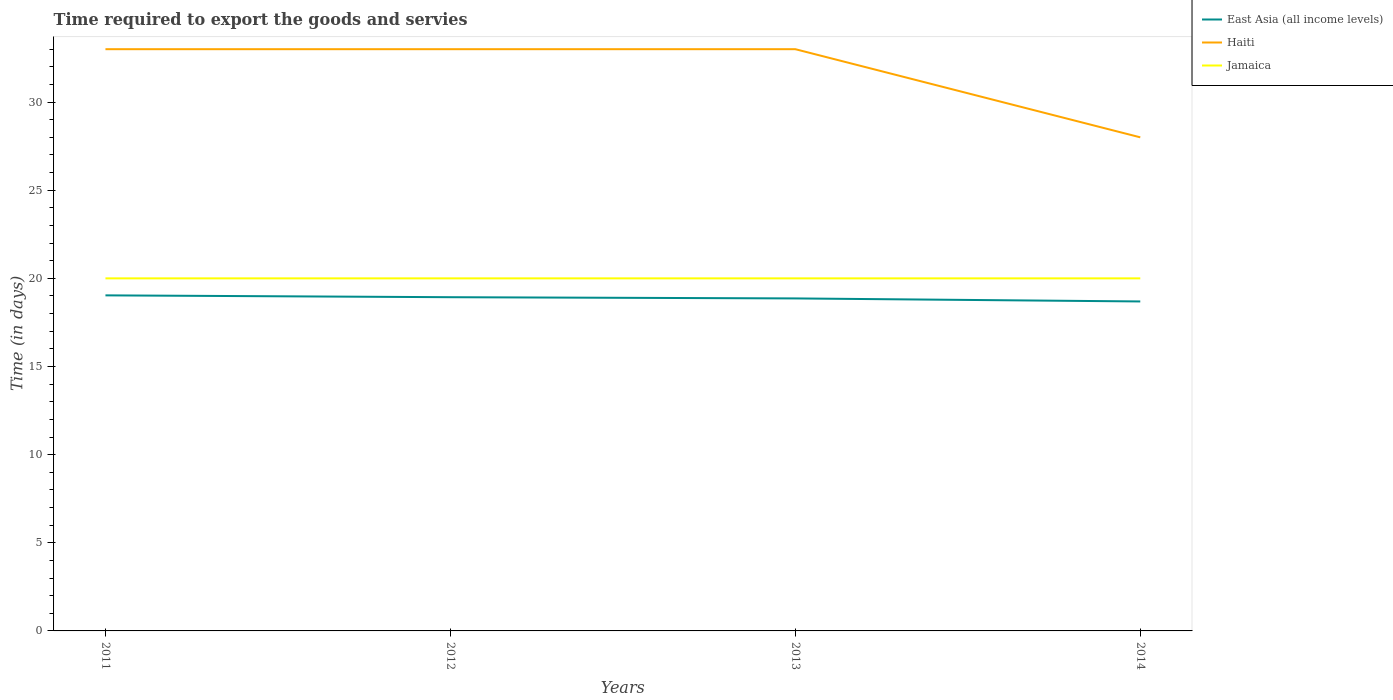Is the number of lines equal to the number of legend labels?
Offer a very short reply. Yes. Across all years, what is the maximum number of days required to export the goods and services in East Asia (all income levels)?
Make the answer very short. 18.69. What is the difference between the highest and the second highest number of days required to export the goods and services in Haiti?
Your answer should be compact. 5. What is the difference between the highest and the lowest number of days required to export the goods and services in Haiti?
Your response must be concise. 3. How many years are there in the graph?
Make the answer very short. 4. What is the difference between two consecutive major ticks on the Y-axis?
Keep it short and to the point. 5. Are the values on the major ticks of Y-axis written in scientific E-notation?
Provide a short and direct response. No. What is the title of the graph?
Give a very brief answer. Time required to export the goods and servies. Does "Ecuador" appear as one of the legend labels in the graph?
Offer a terse response. No. What is the label or title of the X-axis?
Provide a succinct answer. Years. What is the label or title of the Y-axis?
Your answer should be compact. Time (in days). What is the Time (in days) of East Asia (all income levels) in 2011?
Your response must be concise. 19.04. What is the Time (in days) in Jamaica in 2011?
Keep it short and to the point. 20. What is the Time (in days) in East Asia (all income levels) in 2012?
Your answer should be compact. 18.93. What is the Time (in days) in Haiti in 2012?
Your answer should be very brief. 33. What is the Time (in days) of East Asia (all income levels) in 2013?
Your answer should be very brief. 18.86. What is the Time (in days) of Haiti in 2013?
Your response must be concise. 33. What is the Time (in days) of Jamaica in 2013?
Offer a terse response. 20. What is the Time (in days) in East Asia (all income levels) in 2014?
Make the answer very short. 18.69. What is the Time (in days) in Haiti in 2014?
Make the answer very short. 28. What is the Time (in days) of Jamaica in 2014?
Provide a short and direct response. 20. Across all years, what is the maximum Time (in days) in East Asia (all income levels)?
Provide a short and direct response. 19.04. Across all years, what is the maximum Time (in days) in Haiti?
Keep it short and to the point. 33. Across all years, what is the minimum Time (in days) in East Asia (all income levels)?
Your response must be concise. 18.69. Across all years, what is the minimum Time (in days) in Haiti?
Your response must be concise. 28. What is the total Time (in days) of East Asia (all income levels) in the graph?
Offer a very short reply. 75.52. What is the total Time (in days) in Haiti in the graph?
Offer a very short reply. 127. What is the difference between the Time (in days) in East Asia (all income levels) in 2011 and that in 2012?
Your answer should be very brief. 0.1. What is the difference between the Time (in days) in East Asia (all income levels) in 2011 and that in 2013?
Make the answer very short. 0.17. What is the difference between the Time (in days) of Haiti in 2011 and that in 2013?
Provide a short and direct response. 0. What is the difference between the Time (in days) in Jamaica in 2011 and that in 2013?
Give a very brief answer. 0. What is the difference between the Time (in days) in East Asia (all income levels) in 2011 and that in 2014?
Give a very brief answer. 0.35. What is the difference between the Time (in days) in Jamaica in 2011 and that in 2014?
Keep it short and to the point. 0. What is the difference between the Time (in days) in East Asia (all income levels) in 2012 and that in 2013?
Ensure brevity in your answer.  0.07. What is the difference between the Time (in days) of East Asia (all income levels) in 2012 and that in 2014?
Provide a succinct answer. 0.24. What is the difference between the Time (in days) in Haiti in 2012 and that in 2014?
Ensure brevity in your answer.  5. What is the difference between the Time (in days) in Jamaica in 2012 and that in 2014?
Your answer should be compact. 0. What is the difference between the Time (in days) of East Asia (all income levels) in 2013 and that in 2014?
Make the answer very short. 0.17. What is the difference between the Time (in days) in East Asia (all income levels) in 2011 and the Time (in days) in Haiti in 2012?
Make the answer very short. -13.96. What is the difference between the Time (in days) of East Asia (all income levels) in 2011 and the Time (in days) of Jamaica in 2012?
Your answer should be compact. -0.96. What is the difference between the Time (in days) of East Asia (all income levels) in 2011 and the Time (in days) of Haiti in 2013?
Ensure brevity in your answer.  -13.96. What is the difference between the Time (in days) in East Asia (all income levels) in 2011 and the Time (in days) in Jamaica in 2013?
Give a very brief answer. -0.96. What is the difference between the Time (in days) in Haiti in 2011 and the Time (in days) in Jamaica in 2013?
Ensure brevity in your answer.  13. What is the difference between the Time (in days) in East Asia (all income levels) in 2011 and the Time (in days) in Haiti in 2014?
Offer a very short reply. -8.96. What is the difference between the Time (in days) in East Asia (all income levels) in 2011 and the Time (in days) in Jamaica in 2014?
Give a very brief answer. -0.96. What is the difference between the Time (in days) of Haiti in 2011 and the Time (in days) of Jamaica in 2014?
Offer a very short reply. 13. What is the difference between the Time (in days) in East Asia (all income levels) in 2012 and the Time (in days) in Haiti in 2013?
Ensure brevity in your answer.  -14.07. What is the difference between the Time (in days) in East Asia (all income levels) in 2012 and the Time (in days) in Jamaica in 2013?
Make the answer very short. -1.07. What is the difference between the Time (in days) of Haiti in 2012 and the Time (in days) of Jamaica in 2013?
Ensure brevity in your answer.  13. What is the difference between the Time (in days) of East Asia (all income levels) in 2012 and the Time (in days) of Haiti in 2014?
Make the answer very short. -9.07. What is the difference between the Time (in days) in East Asia (all income levels) in 2012 and the Time (in days) in Jamaica in 2014?
Make the answer very short. -1.07. What is the difference between the Time (in days) of East Asia (all income levels) in 2013 and the Time (in days) of Haiti in 2014?
Ensure brevity in your answer.  -9.14. What is the difference between the Time (in days) in East Asia (all income levels) in 2013 and the Time (in days) in Jamaica in 2014?
Give a very brief answer. -1.14. What is the difference between the Time (in days) of Haiti in 2013 and the Time (in days) of Jamaica in 2014?
Make the answer very short. 13. What is the average Time (in days) in East Asia (all income levels) per year?
Keep it short and to the point. 18.88. What is the average Time (in days) in Haiti per year?
Your response must be concise. 31.75. What is the average Time (in days) in Jamaica per year?
Offer a terse response. 20. In the year 2011, what is the difference between the Time (in days) of East Asia (all income levels) and Time (in days) of Haiti?
Your response must be concise. -13.96. In the year 2011, what is the difference between the Time (in days) in East Asia (all income levels) and Time (in days) in Jamaica?
Make the answer very short. -0.96. In the year 2012, what is the difference between the Time (in days) in East Asia (all income levels) and Time (in days) in Haiti?
Keep it short and to the point. -14.07. In the year 2012, what is the difference between the Time (in days) in East Asia (all income levels) and Time (in days) in Jamaica?
Provide a succinct answer. -1.07. In the year 2013, what is the difference between the Time (in days) in East Asia (all income levels) and Time (in days) in Haiti?
Provide a short and direct response. -14.14. In the year 2013, what is the difference between the Time (in days) of East Asia (all income levels) and Time (in days) of Jamaica?
Keep it short and to the point. -1.14. In the year 2013, what is the difference between the Time (in days) in Haiti and Time (in days) in Jamaica?
Give a very brief answer. 13. In the year 2014, what is the difference between the Time (in days) of East Asia (all income levels) and Time (in days) of Haiti?
Offer a terse response. -9.31. In the year 2014, what is the difference between the Time (in days) of East Asia (all income levels) and Time (in days) of Jamaica?
Your response must be concise. -1.31. In the year 2014, what is the difference between the Time (in days) in Haiti and Time (in days) in Jamaica?
Keep it short and to the point. 8. What is the ratio of the Time (in days) of East Asia (all income levels) in 2011 to that in 2012?
Your response must be concise. 1.01. What is the ratio of the Time (in days) in Haiti in 2011 to that in 2012?
Offer a terse response. 1. What is the ratio of the Time (in days) of East Asia (all income levels) in 2011 to that in 2013?
Keep it short and to the point. 1.01. What is the ratio of the Time (in days) in Haiti in 2011 to that in 2013?
Give a very brief answer. 1. What is the ratio of the Time (in days) in Jamaica in 2011 to that in 2013?
Make the answer very short. 1. What is the ratio of the Time (in days) of East Asia (all income levels) in 2011 to that in 2014?
Offer a very short reply. 1.02. What is the ratio of the Time (in days) of Haiti in 2011 to that in 2014?
Provide a succinct answer. 1.18. What is the ratio of the Time (in days) of Jamaica in 2011 to that in 2014?
Your answer should be very brief. 1. What is the ratio of the Time (in days) in East Asia (all income levels) in 2012 to that in 2014?
Give a very brief answer. 1.01. What is the ratio of the Time (in days) of Haiti in 2012 to that in 2014?
Give a very brief answer. 1.18. What is the ratio of the Time (in days) in Jamaica in 2012 to that in 2014?
Provide a short and direct response. 1. What is the ratio of the Time (in days) in East Asia (all income levels) in 2013 to that in 2014?
Keep it short and to the point. 1.01. What is the ratio of the Time (in days) in Haiti in 2013 to that in 2014?
Provide a succinct answer. 1.18. What is the ratio of the Time (in days) in Jamaica in 2013 to that in 2014?
Give a very brief answer. 1. What is the difference between the highest and the second highest Time (in days) in East Asia (all income levels)?
Give a very brief answer. 0.1. What is the difference between the highest and the second highest Time (in days) of Haiti?
Your response must be concise. 0. What is the difference between the highest and the second highest Time (in days) of Jamaica?
Provide a succinct answer. 0. What is the difference between the highest and the lowest Time (in days) in East Asia (all income levels)?
Give a very brief answer. 0.35. What is the difference between the highest and the lowest Time (in days) in Haiti?
Provide a short and direct response. 5. What is the difference between the highest and the lowest Time (in days) of Jamaica?
Offer a very short reply. 0. 